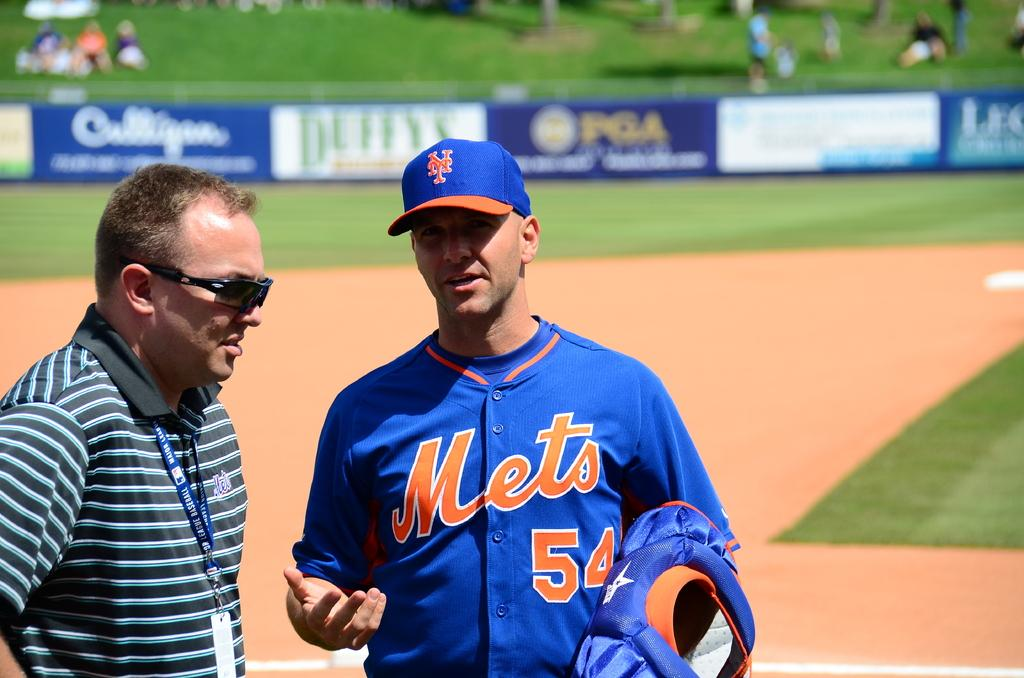<image>
Write a terse but informative summary of the picture. A man wearing a baseball shirt that says Mets 54 talking to a man in glasses 